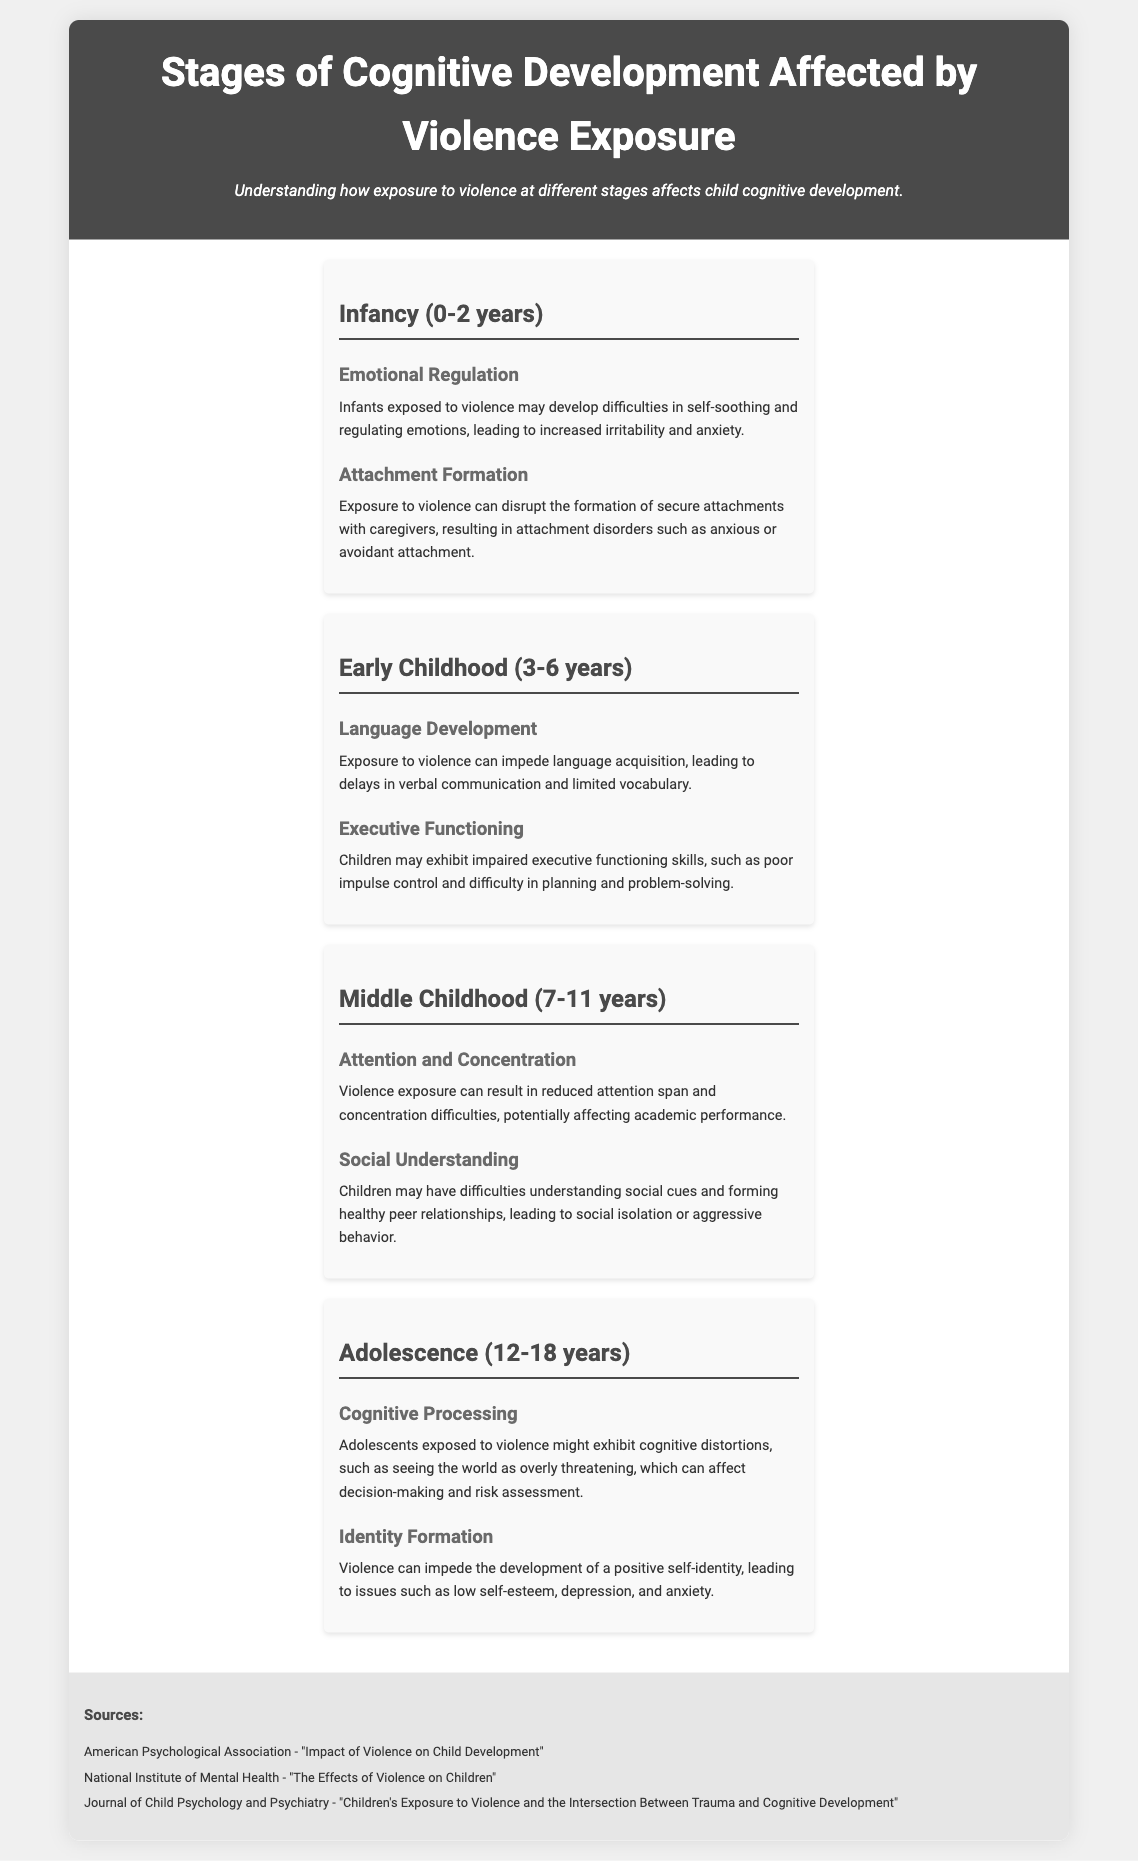What stage is affected by violence exposure from 0 to 2 years? The document lists "Infancy (0-2 years)" as the stage affected.
Answer: Infancy (0-2 years) What cognitive effect is associated with Early Childhood? The document states that "Language Development" is affected during this stage.
Answer: Language Development How many stages of cognitive development are discussed in the document? The document describes a total of four stages.
Answer: Four What emotional response might infants exposed to violence struggle with? The document indicates that they may have difficulties in "Emotional Regulation."
Answer: Emotional Regulation Which cognitive aspect is impacted during Adolescence according to the document? The document mentions "Cognitive Processing" as an affected cognitive aspect.
Answer: Cognitive Processing What type of attachment issues can arise in Infants due to violence exposure? The document states they can develop "attachment disorders."
Answer: Attachment disorders What are the two specific effects listed for Middle Childhood? The document lists "Attention and Concentration" and "Social Understanding" as effects.
Answer: Attention and Concentration, Social Understanding Which organization is cited as a source in the document? The document references "American Psychological Association."
Answer: American Psychological Association What is the emotional condition that violence exposure may impede in adolescents? The document states it could lead to issues such as "low self-esteem."
Answer: Low self-esteem 